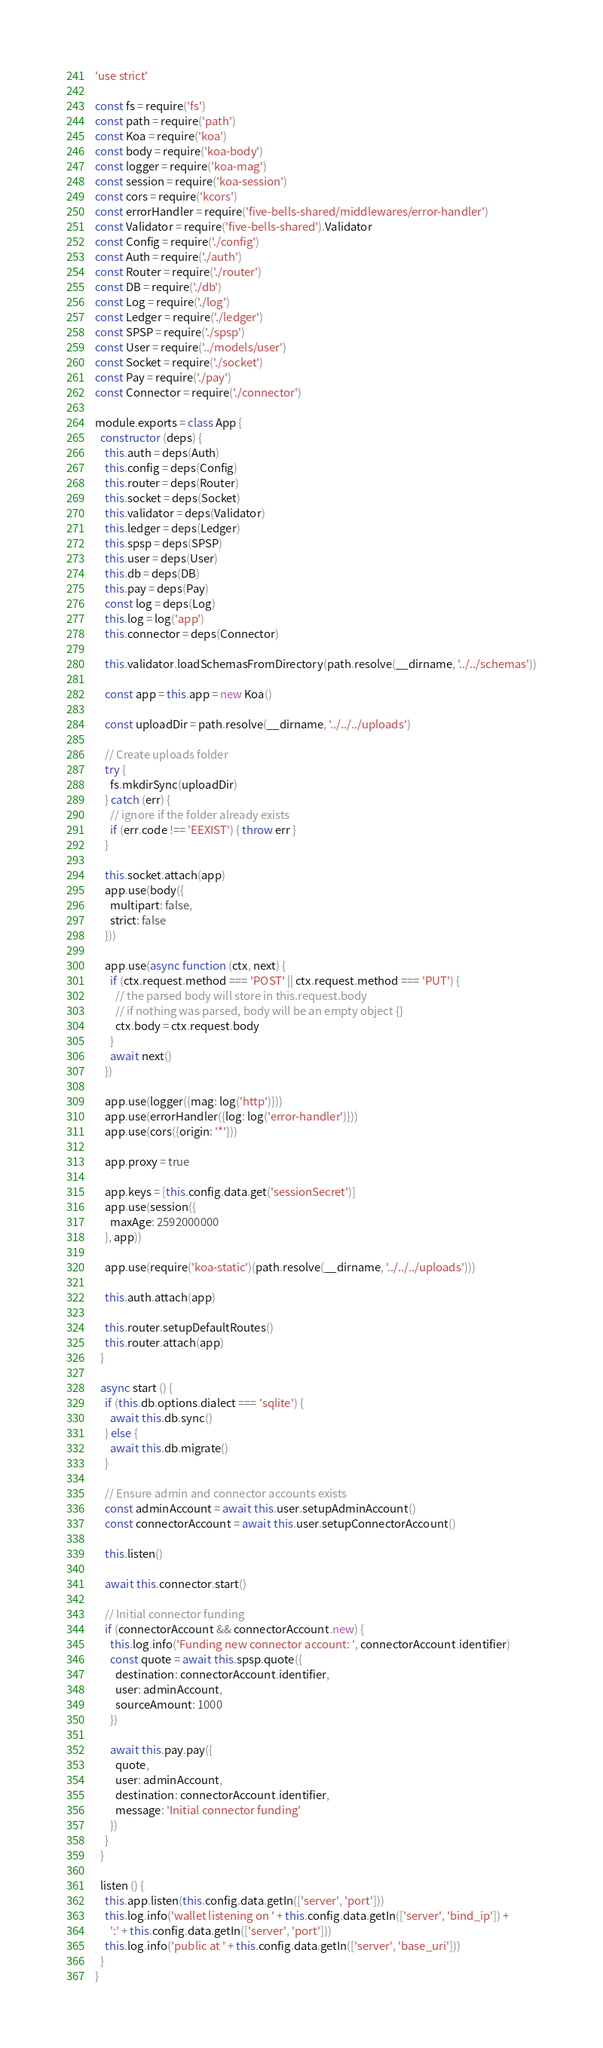Convert code to text. <code><loc_0><loc_0><loc_500><loc_500><_JavaScript_>'use strict'

const fs = require('fs')
const path = require('path')
const Koa = require('koa')
const body = require('koa-body')
const logger = require('koa-mag')
const session = require('koa-session')
const cors = require('kcors')
const errorHandler = require('five-bells-shared/middlewares/error-handler')
const Validator = require('five-bells-shared').Validator
const Config = require('./config')
const Auth = require('./auth')
const Router = require('./router')
const DB = require('./db')
const Log = require('./log')
const Ledger = require('./ledger')
const SPSP = require('./spsp')
const User = require('../models/user')
const Socket = require('./socket')
const Pay = require('./pay')
const Connector = require('./connector')

module.exports = class App {
  constructor (deps) {
    this.auth = deps(Auth)
    this.config = deps(Config)
    this.router = deps(Router)
    this.socket = deps(Socket)
    this.validator = deps(Validator)
    this.ledger = deps(Ledger)
    this.spsp = deps(SPSP)
    this.user = deps(User)
    this.db = deps(DB)
    this.pay = deps(Pay)
    const log = deps(Log)
    this.log = log('app')
    this.connector = deps(Connector)

    this.validator.loadSchemasFromDirectory(path.resolve(__dirname, '../../schemas'))

    const app = this.app = new Koa()

    const uploadDir = path.resolve(__dirname, '../../../uploads')

    // Create uploads folder
    try {
      fs.mkdirSync(uploadDir)
    } catch (err) {
      // ignore if the folder already exists
      if (err.code !== 'EEXIST') { throw err }
    }

    this.socket.attach(app)
    app.use(body({
      multipart: false,
      strict: false
    }))

    app.use(async function (ctx, next) {
      if (ctx.request.method === 'POST' || ctx.request.method === 'PUT') {
        // the parsed body will store in this.request.body
        // if nothing was parsed, body will be an empty object {}
        ctx.body = ctx.request.body
      }
      await next()
    })

    app.use(logger({mag: log('http')}))
    app.use(errorHandler({log: log('error-handler')}))
    app.use(cors({origin: '*'}))

    app.proxy = true

    app.keys = [this.config.data.get('sessionSecret')]
    app.use(session({
      maxAge: 2592000000
    }, app))

    app.use(require('koa-static')(path.resolve(__dirname, '../../../uploads')))

    this.auth.attach(app)

    this.router.setupDefaultRoutes()
    this.router.attach(app)
  }

  async start () {
    if (this.db.options.dialect === 'sqlite') {
      await this.db.sync()
    } else {
      await this.db.migrate()
    }

    // Ensure admin and connector accounts exists
    const adminAccount = await this.user.setupAdminAccount()
    const connectorAccount = await this.user.setupConnectorAccount()

    this.listen()

    await this.connector.start()

    // Initial connector funding
    if (connectorAccount && connectorAccount.new) {
      this.log.info('Funding new connector account: ', connectorAccount.identifier)
      const quote = await this.spsp.quote({
        destination: connectorAccount.identifier,
        user: adminAccount,
        sourceAmount: 1000
      })

      await this.pay.pay({
        quote,
        user: adminAccount,
        destination: connectorAccount.identifier,
        message: 'Initial connector funding'
      })
    }
  }

  listen () {
    this.app.listen(this.config.data.getIn(['server', 'port']))
    this.log.info('wallet listening on ' + this.config.data.getIn(['server', 'bind_ip']) +
      ':' + this.config.data.getIn(['server', 'port']))
    this.log.info('public at ' + this.config.data.getIn(['server', 'base_uri']))
  }
}
</code> 